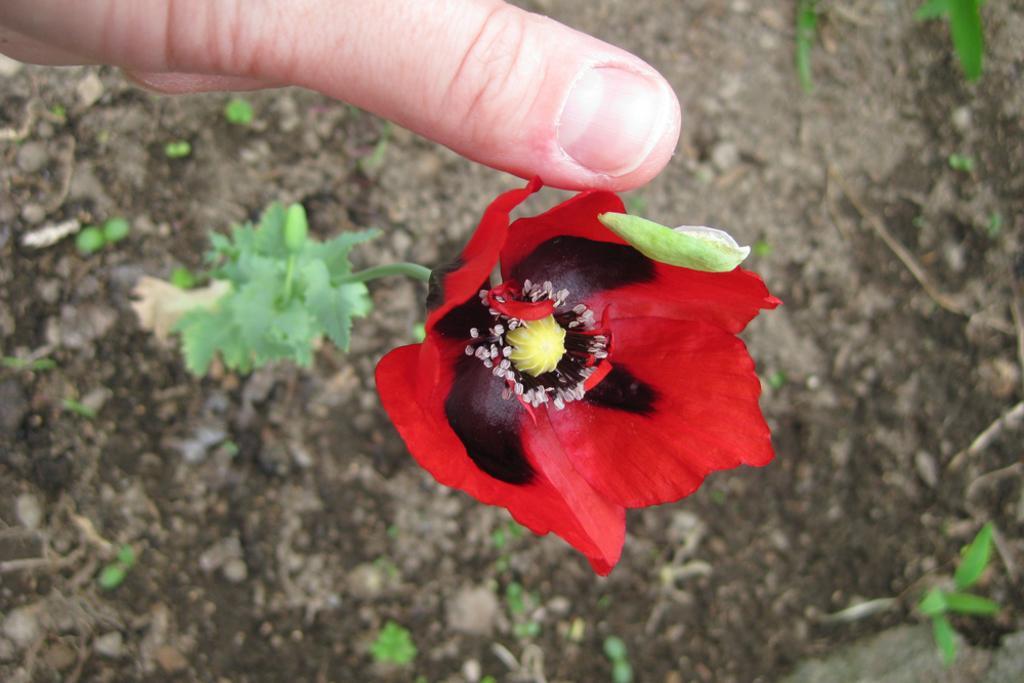Please provide a concise description of this image. In the image there is a red flower to a plant and a person is touching the flower with thumb finger, there is a lot of soil around the plant. 